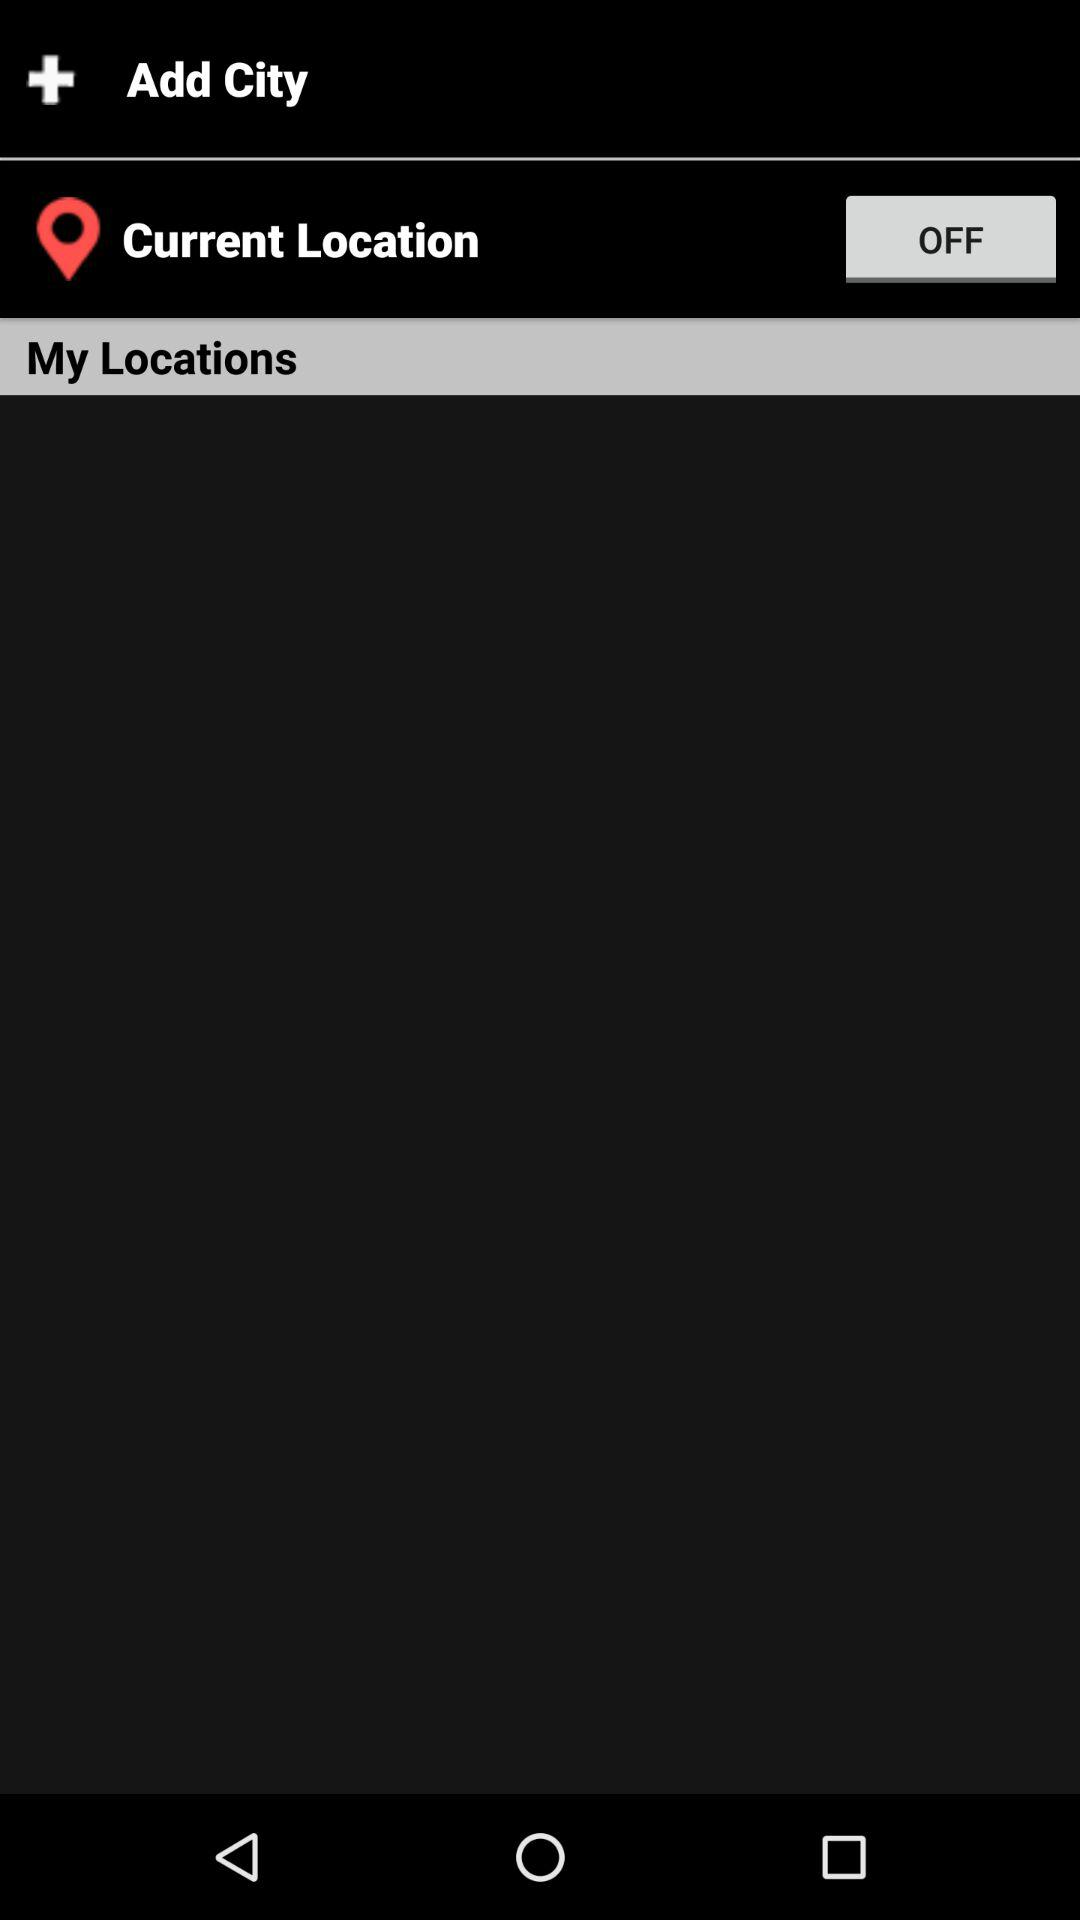What is the status of the "Current Location"? The status is "off". 